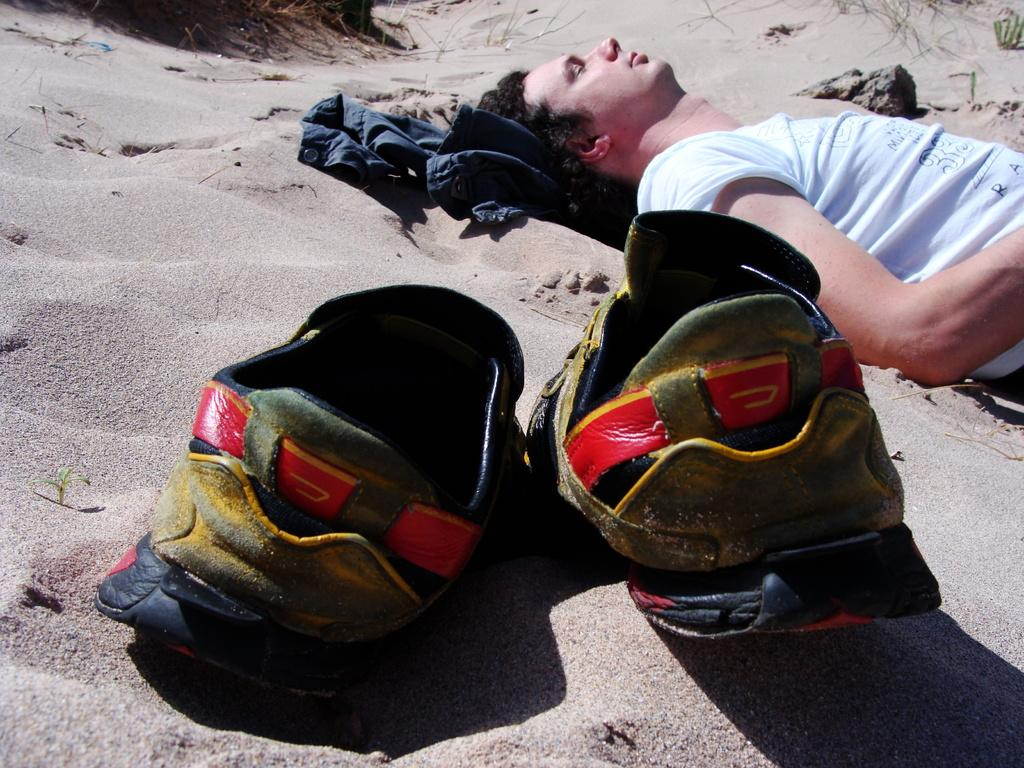Who is present in the image? There is a man in the image. What is the man doing in the image? The man is laying on the sand. What object can be seen in the middle of the image? There is a pair of shoes in the middle of the image. What story is the man telling to his father in the image? There is no indication in the image that the man is telling a story or interacting with a father. 